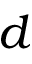<formula> <loc_0><loc_0><loc_500><loc_500>d</formula> 